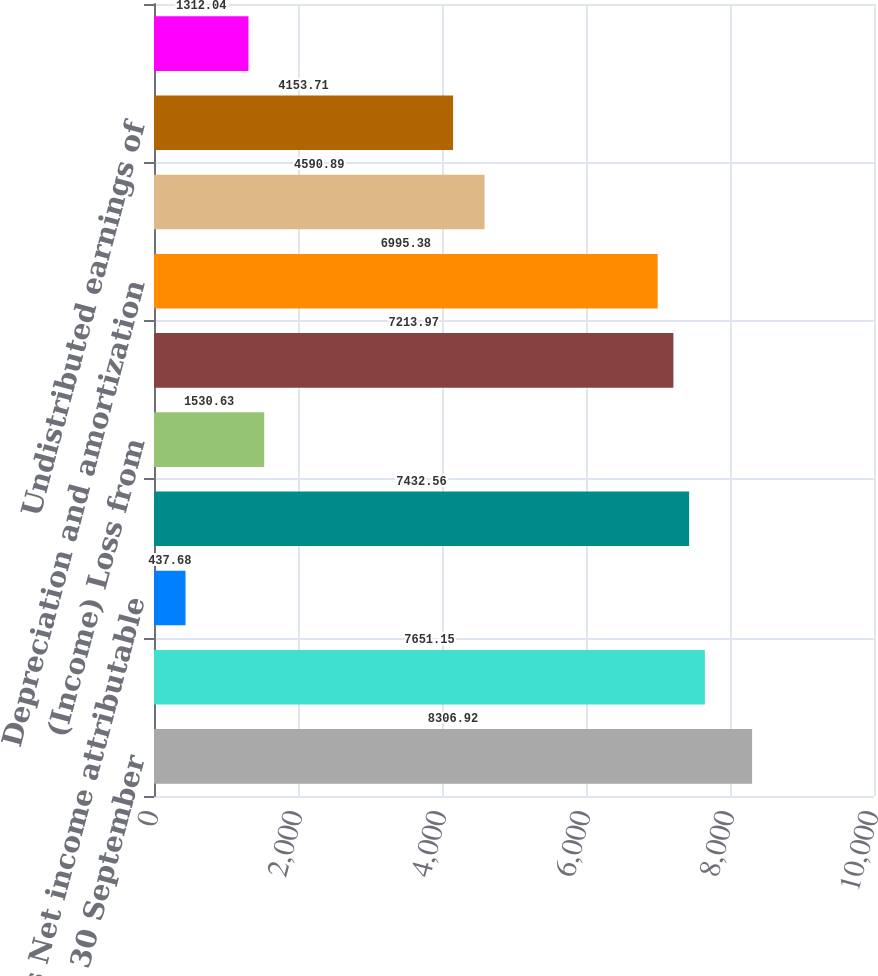<chart> <loc_0><loc_0><loc_500><loc_500><bar_chart><fcel>Year ended 30 September<fcel>Net Income<fcel>Less Net income attributable<fcel>Net income attributable to Air<fcel>(Income) Loss from<fcel>Income from continuing<fcel>Depreciation and amortization<fcel>Deferred income taxes<fcel>Undistributed earnings of<fcel>Loss (Gain) on sale of assets<nl><fcel>8306.92<fcel>7651.15<fcel>437.68<fcel>7432.56<fcel>1530.63<fcel>7213.97<fcel>6995.38<fcel>4590.89<fcel>4153.71<fcel>1312.04<nl></chart> 